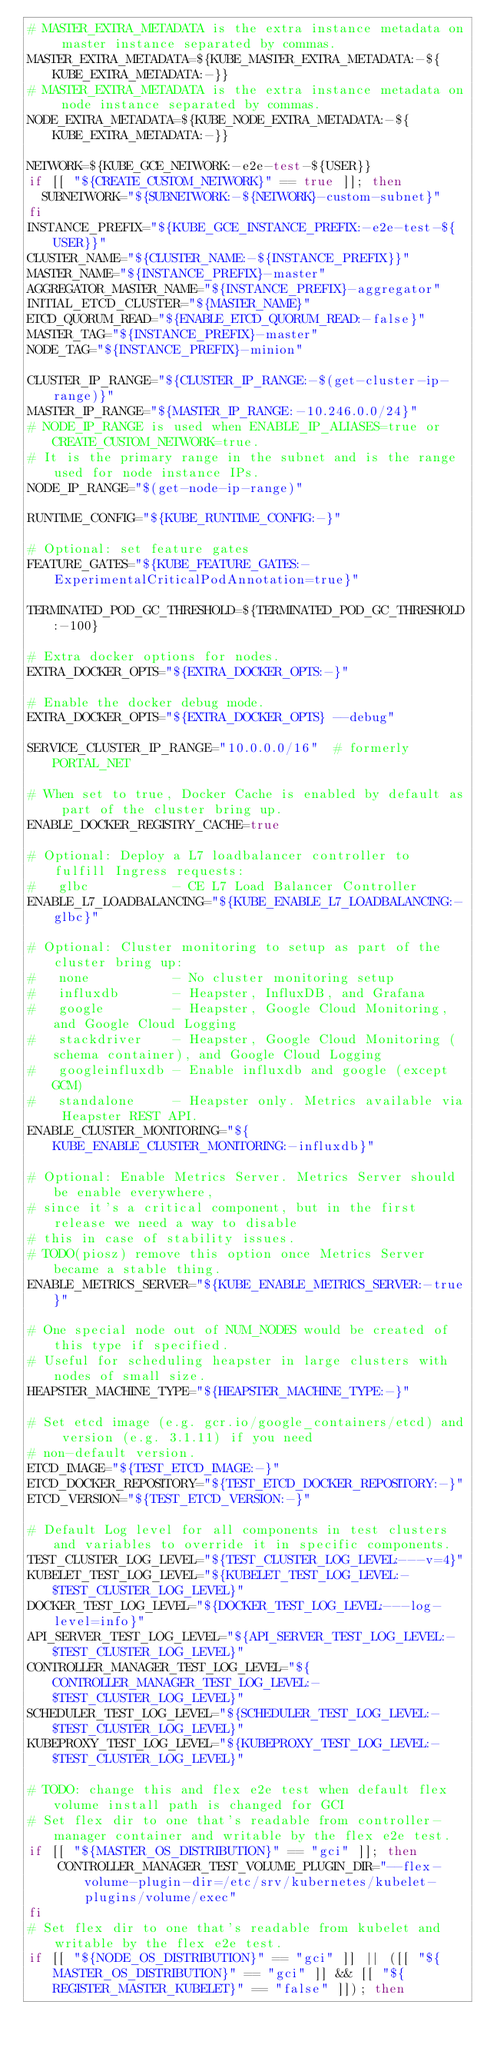Convert code to text. <code><loc_0><loc_0><loc_500><loc_500><_Bash_># MASTER_EXTRA_METADATA is the extra instance metadata on master instance separated by commas.
MASTER_EXTRA_METADATA=${KUBE_MASTER_EXTRA_METADATA:-${KUBE_EXTRA_METADATA:-}}
# MASTER_EXTRA_METADATA is the extra instance metadata on node instance separated by commas.
NODE_EXTRA_METADATA=${KUBE_NODE_EXTRA_METADATA:-${KUBE_EXTRA_METADATA:-}}

NETWORK=${KUBE_GCE_NETWORK:-e2e-test-${USER}}
if [[ "${CREATE_CUSTOM_NETWORK}" == true ]]; then
  SUBNETWORK="${SUBNETWORK:-${NETWORK}-custom-subnet}"
fi
INSTANCE_PREFIX="${KUBE_GCE_INSTANCE_PREFIX:-e2e-test-${USER}}"
CLUSTER_NAME="${CLUSTER_NAME:-${INSTANCE_PREFIX}}"
MASTER_NAME="${INSTANCE_PREFIX}-master"
AGGREGATOR_MASTER_NAME="${INSTANCE_PREFIX}-aggregator"
INITIAL_ETCD_CLUSTER="${MASTER_NAME}"
ETCD_QUORUM_READ="${ENABLE_ETCD_QUORUM_READ:-false}"
MASTER_TAG="${INSTANCE_PREFIX}-master"
NODE_TAG="${INSTANCE_PREFIX}-minion"

CLUSTER_IP_RANGE="${CLUSTER_IP_RANGE:-$(get-cluster-ip-range)}"
MASTER_IP_RANGE="${MASTER_IP_RANGE:-10.246.0.0/24}"
# NODE_IP_RANGE is used when ENABLE_IP_ALIASES=true or CREATE_CUSTOM_NETWORK=true.
# It is the primary range in the subnet and is the range used for node instance IPs.
NODE_IP_RANGE="$(get-node-ip-range)"

RUNTIME_CONFIG="${KUBE_RUNTIME_CONFIG:-}"

# Optional: set feature gates
FEATURE_GATES="${KUBE_FEATURE_GATES:-ExperimentalCriticalPodAnnotation=true}"

TERMINATED_POD_GC_THRESHOLD=${TERMINATED_POD_GC_THRESHOLD:-100}

# Extra docker options for nodes.
EXTRA_DOCKER_OPTS="${EXTRA_DOCKER_OPTS:-}"

# Enable the docker debug mode.
EXTRA_DOCKER_OPTS="${EXTRA_DOCKER_OPTS} --debug"

SERVICE_CLUSTER_IP_RANGE="10.0.0.0/16"  # formerly PORTAL_NET

# When set to true, Docker Cache is enabled by default as part of the cluster bring up.
ENABLE_DOCKER_REGISTRY_CACHE=true

# Optional: Deploy a L7 loadbalancer controller to fulfill Ingress requests:
#   glbc           - CE L7 Load Balancer Controller
ENABLE_L7_LOADBALANCING="${KUBE_ENABLE_L7_LOADBALANCING:-glbc}"

# Optional: Cluster monitoring to setup as part of the cluster bring up:
#   none           - No cluster monitoring setup
#   influxdb       - Heapster, InfluxDB, and Grafana
#   google         - Heapster, Google Cloud Monitoring, and Google Cloud Logging
#   stackdriver    - Heapster, Google Cloud Monitoring (schema container), and Google Cloud Logging
#   googleinfluxdb - Enable influxdb and google (except GCM)
#   standalone     - Heapster only. Metrics available via Heapster REST API.
ENABLE_CLUSTER_MONITORING="${KUBE_ENABLE_CLUSTER_MONITORING:-influxdb}"

# Optional: Enable Metrics Server. Metrics Server should be enable everywhere,
# since it's a critical component, but in the first release we need a way to disable
# this in case of stability issues.
# TODO(piosz) remove this option once Metrics Server became a stable thing.
ENABLE_METRICS_SERVER="${KUBE_ENABLE_METRICS_SERVER:-true}"

# One special node out of NUM_NODES would be created of this type if specified.
# Useful for scheduling heapster in large clusters with nodes of small size.
HEAPSTER_MACHINE_TYPE="${HEAPSTER_MACHINE_TYPE:-}"

# Set etcd image (e.g. gcr.io/google_containers/etcd) and version (e.g. 3.1.11) if you need
# non-default version.
ETCD_IMAGE="${TEST_ETCD_IMAGE:-}"
ETCD_DOCKER_REPOSITORY="${TEST_ETCD_DOCKER_REPOSITORY:-}"
ETCD_VERSION="${TEST_ETCD_VERSION:-}"

# Default Log level for all components in test clusters and variables to override it in specific components.
TEST_CLUSTER_LOG_LEVEL="${TEST_CLUSTER_LOG_LEVEL:---v=4}"
KUBELET_TEST_LOG_LEVEL="${KUBELET_TEST_LOG_LEVEL:-$TEST_CLUSTER_LOG_LEVEL}"
DOCKER_TEST_LOG_LEVEL="${DOCKER_TEST_LOG_LEVEL:---log-level=info}"
API_SERVER_TEST_LOG_LEVEL="${API_SERVER_TEST_LOG_LEVEL:-$TEST_CLUSTER_LOG_LEVEL}"
CONTROLLER_MANAGER_TEST_LOG_LEVEL="${CONTROLLER_MANAGER_TEST_LOG_LEVEL:-$TEST_CLUSTER_LOG_LEVEL}"
SCHEDULER_TEST_LOG_LEVEL="${SCHEDULER_TEST_LOG_LEVEL:-$TEST_CLUSTER_LOG_LEVEL}"
KUBEPROXY_TEST_LOG_LEVEL="${KUBEPROXY_TEST_LOG_LEVEL:-$TEST_CLUSTER_LOG_LEVEL}"

# TODO: change this and flex e2e test when default flex volume install path is changed for GCI
# Set flex dir to one that's readable from controller-manager container and writable by the flex e2e test.
if [[ "${MASTER_OS_DISTRIBUTION}" == "gci" ]]; then
    CONTROLLER_MANAGER_TEST_VOLUME_PLUGIN_DIR="--flex-volume-plugin-dir=/etc/srv/kubernetes/kubelet-plugins/volume/exec"
fi
# Set flex dir to one that's readable from kubelet and writable by the flex e2e test.
if [[ "${NODE_OS_DISTRIBUTION}" == "gci" ]] || ([[ "${MASTER_OS_DISTRIBUTION}" == "gci" ]] && [[ "${REGISTER_MASTER_KUBELET}" == "false" ]]); then</code> 